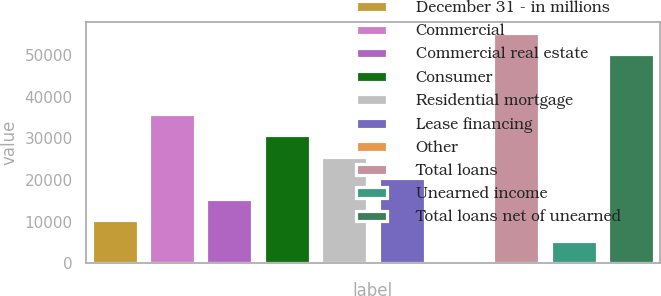<chart> <loc_0><loc_0><loc_500><loc_500><bar_chart><fcel>December 31 - in millions<fcel>Commercial<fcel>Commercial real estate<fcel>Consumer<fcel>Residential mortgage<fcel>Lease financing<fcel>Other<fcel>Total loans<fcel>Unearned income<fcel>Total loans net of unearned<nl><fcel>10480.8<fcel>35742.8<fcel>15533.2<fcel>30690.4<fcel>25638<fcel>20585.6<fcel>376<fcel>55157.4<fcel>5428.4<fcel>50105<nl></chart> 